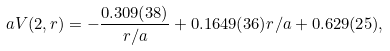<formula> <loc_0><loc_0><loc_500><loc_500>a V ( 2 , r ) = - \frac { 0 . 3 0 9 ( 3 8 ) } { r / a } + 0 . 1 6 4 9 ( 3 6 ) r / a + 0 . 6 2 9 ( 2 5 ) ,</formula> 